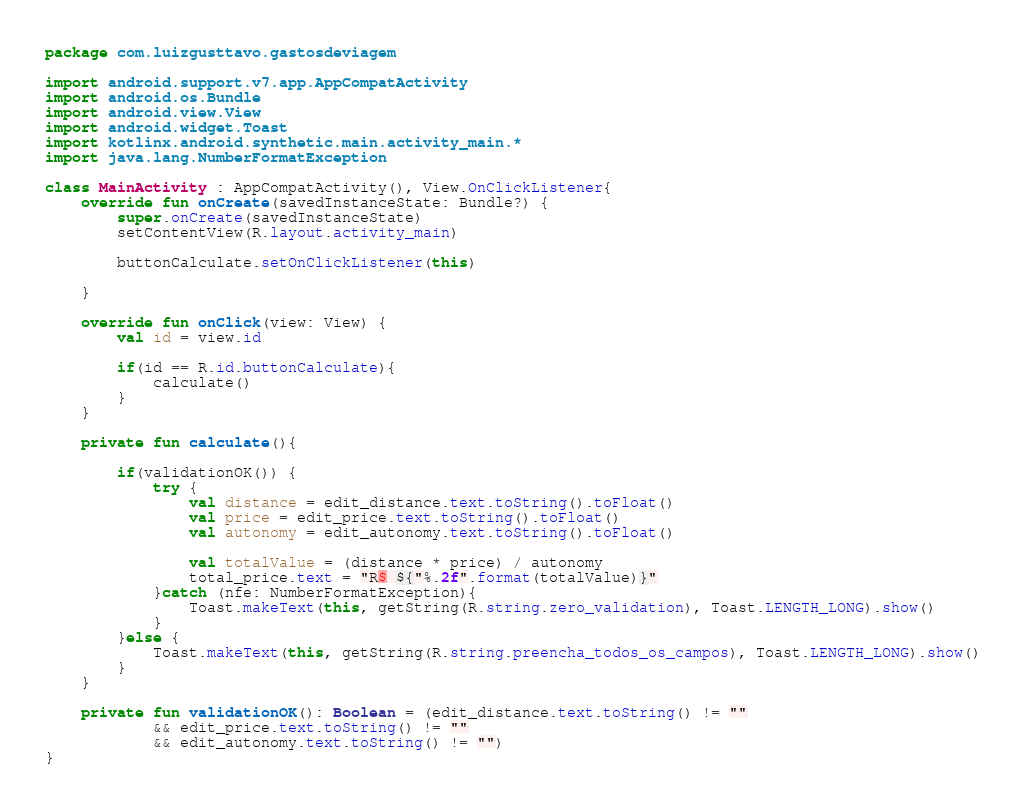Convert code to text. <code><loc_0><loc_0><loc_500><loc_500><_Kotlin_>package com.luizgusttavo.gastosdeviagem

import android.support.v7.app.AppCompatActivity
import android.os.Bundle
import android.view.View
import android.widget.Toast
import kotlinx.android.synthetic.main.activity_main.*
import java.lang.NumberFormatException

class MainActivity : AppCompatActivity(), View.OnClickListener{
    override fun onCreate(savedInstanceState: Bundle?) {
        super.onCreate(savedInstanceState)
        setContentView(R.layout.activity_main)

        buttonCalculate.setOnClickListener(this)

    }

    override fun onClick(view: View) {
        val id = view.id

        if(id == R.id.buttonCalculate){
            calculate()
        }
    }

    private fun calculate(){

        if(validationOK()) {
            try {
                val distance = edit_distance.text.toString().toFloat()
                val price = edit_price.text.toString().toFloat()
                val autonomy = edit_autonomy.text.toString().toFloat()

                val totalValue = (distance * price) / autonomy
                total_price.text = "R$ ${"%.2f".format(totalValue)}"
            }catch (nfe: NumberFormatException){
                Toast.makeText(this, getString(R.string.zero_validation), Toast.LENGTH_LONG).show()
            }
        }else {
            Toast.makeText(this, getString(R.string.preencha_todos_os_campos), Toast.LENGTH_LONG).show()
        }
    }

    private fun validationOK(): Boolean = (edit_distance.text.toString() != ""
            && edit_price.text.toString() != ""
            && edit_autonomy.text.toString() != "")
}</code> 